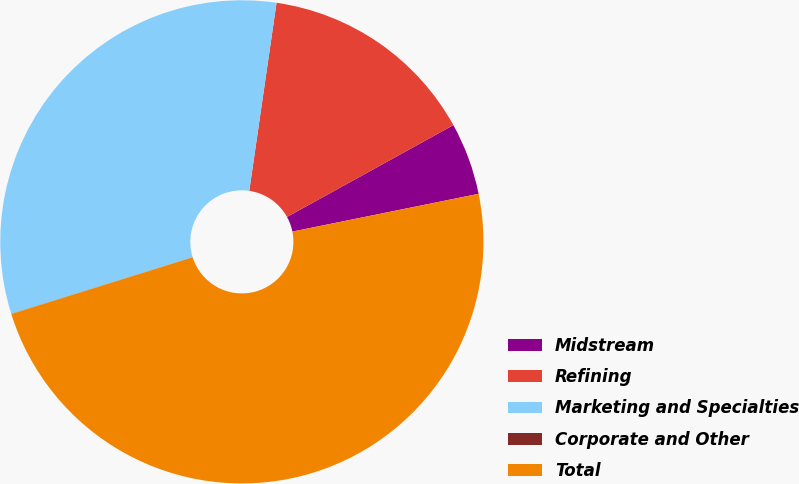<chart> <loc_0><loc_0><loc_500><loc_500><pie_chart><fcel>Midstream<fcel>Refining<fcel>Marketing and Specialties<fcel>Corporate and Other<fcel>Total<nl><fcel>4.84%<fcel>14.68%<fcel>32.11%<fcel>0.01%<fcel>48.36%<nl></chart> 